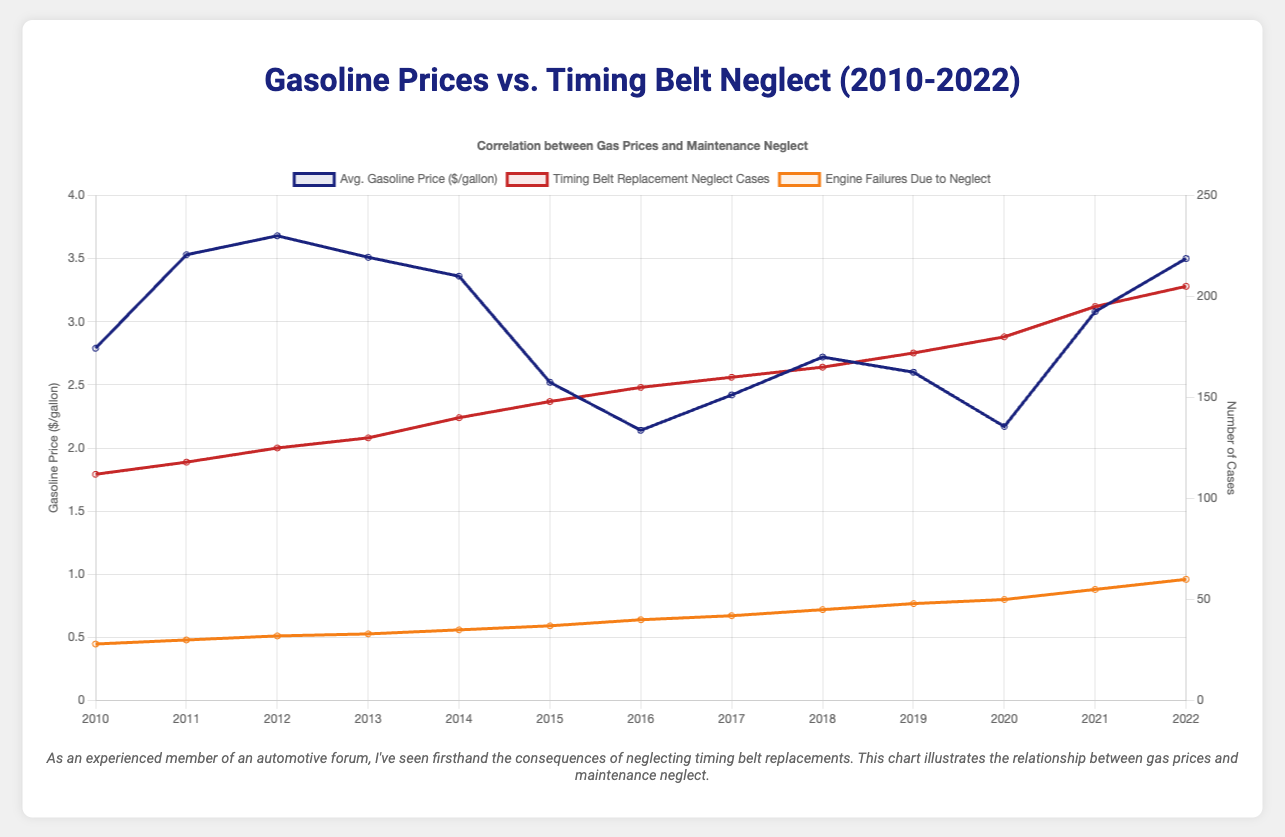What's the average gasoline price from 2010 to 2022? To find the average gasoline price, sum all the prices from 2010 to 2022 and divide by the number of years. The prices are [2.79, 3.53, 3.68, 3.51, 3.36, 2.52, 2.14, 2.42, 2.72, 2.60, 2.17, 3.08, 3.50], which sum to 39.02. There are 13 years, so the average is 39.02 / 13
Answer: 3.00 In which year did neglect cases for timing belt replacement exceed 150 for the first time? Check the plotted trend for timing belt replacement neglect cases and identify when the value first exceeds 150. It can be observed around 2016, where the value is 155.
Answer: 2016 Which year shows the lowest average gasoline price, and what was that price? Look for the smallest value in the average gasoline price line plot. The lowest value is $2.14 which occurred in 2016.
Answer: 2016, $2.14 How many more engine failures due to neglect were there in 2022 compared to 2010? Subtract the number of engine failures in 2010 from those in 2022. In 2010, there were 28 engine failures and in 2022, there were 60. The difference is 60 - 28.
Answer: 32 When comparing 2012 and 2022, which year had higher neglect cases for timing belt replacements and by how much? Find the values for timing belt replacement neglect cases for 2012 and 2022. In 2012, the number was 125, and in 2022, it was 205. Then find the difference: 205 - 125.
Answer: 2022, 80 more What is the trend of gasoline prices from 2015 to 2020? Examine the line plot of average gasoline prices from 2015 ($2.52) to 2020 ($2.17). The prices initially decreased to 2016 ($2.14), then showed a slight increase until 2018 ($2.72), and thereafter, a slight decrease towards 2020.
Answer: Decreasing to increasing, then decreasing Was there any year where both the gasoline price and timing belt replacement neglect cases increased simultaneously? Check the yearly trends for both gasoline price and timing belt replacement neglect cases. In 2021, both metrics showed an increase from $2.17 to $3.08 for gasoline price and from 180 to 195 for neglect cases.
Answer: 2021 Which year had the highest number of engine failures due to neglect and what was the number? Look for the maximum value in the engine failures due to neglect line. The highest value is 60, which occurred in 2022.
Answer: 2022, 60 Is there an observable pattern comparing the gasoline price fluctuation to engine failures due to neglect? Assess the relation between the gasoline price and engine failure trends. Generally, as the gasoline price fluctuates, the engine failures due to neglect steadily increase, indicating a potential indirect relationship.
Answer: Engine failures increase steadily while gasoline prices fluctuate 